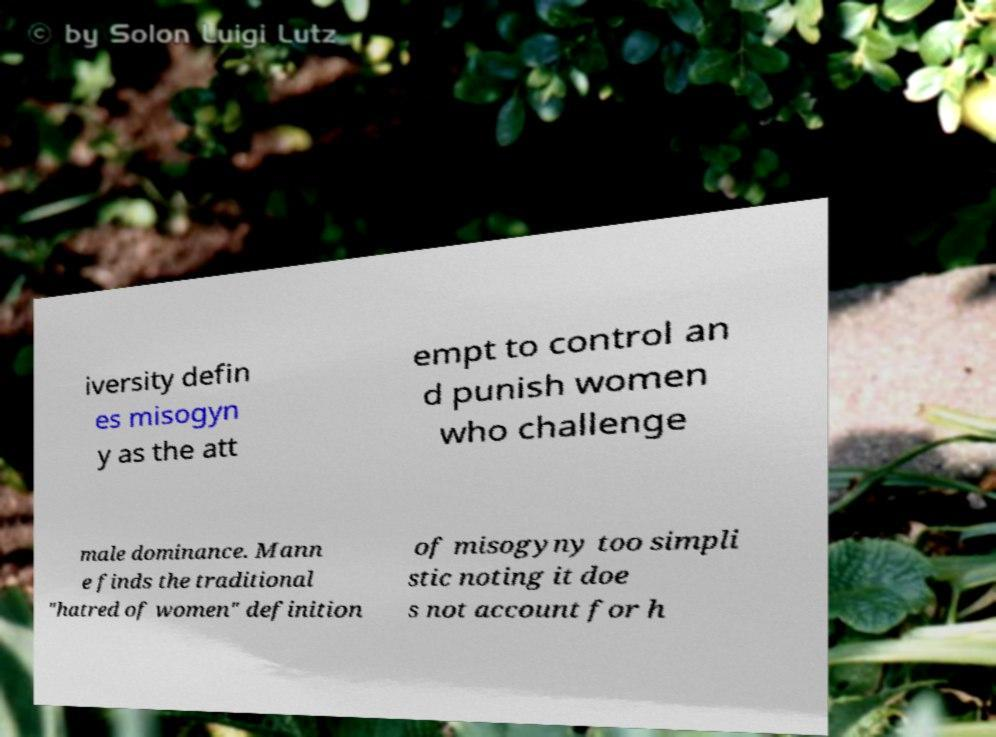Could you assist in decoding the text presented in this image and type it out clearly? iversity defin es misogyn y as the att empt to control an d punish women who challenge male dominance. Mann e finds the traditional "hatred of women" definition of misogyny too simpli stic noting it doe s not account for h 